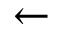<formula> <loc_0><loc_0><loc_500><loc_500>\leftarrow</formula> 